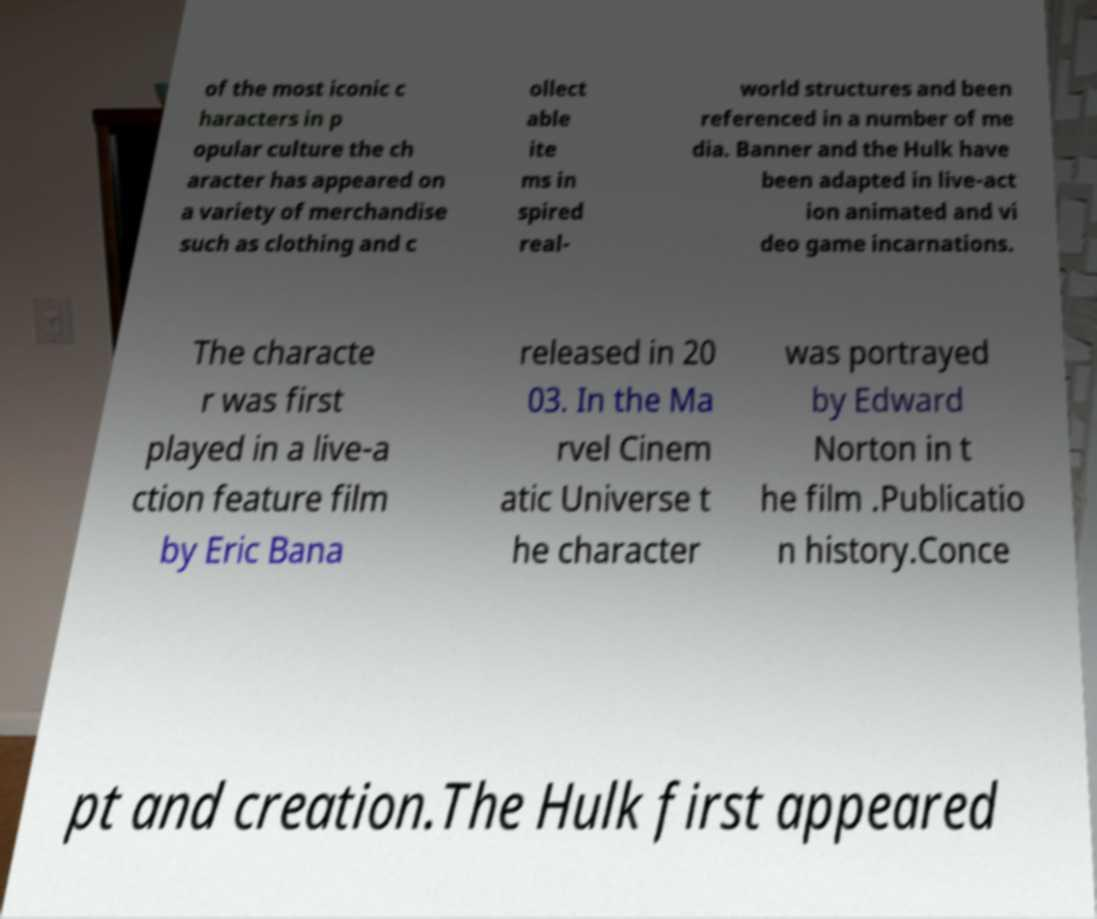Please read and relay the text visible in this image. What does it say? of the most iconic c haracters in p opular culture the ch aracter has appeared on a variety of merchandise such as clothing and c ollect able ite ms in spired real- world structures and been referenced in a number of me dia. Banner and the Hulk have been adapted in live-act ion animated and vi deo game incarnations. The characte r was first played in a live-a ction feature film by Eric Bana released in 20 03. In the Ma rvel Cinem atic Universe t he character was portrayed by Edward Norton in t he film .Publicatio n history.Conce pt and creation.The Hulk first appeared 